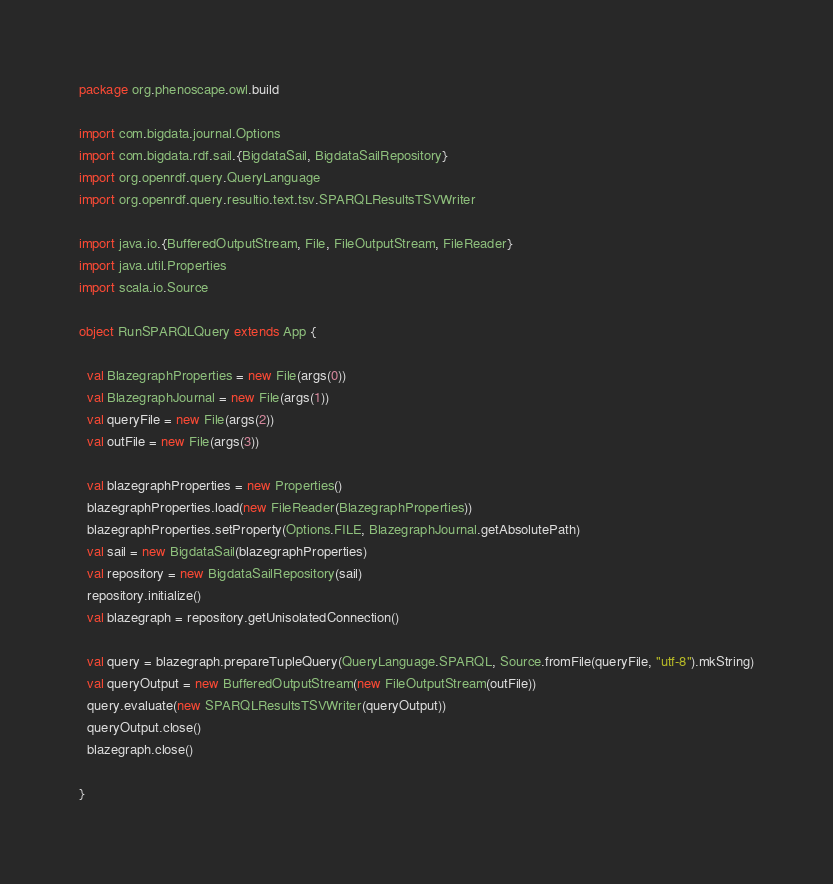Convert code to text. <code><loc_0><loc_0><loc_500><loc_500><_Scala_>package org.phenoscape.owl.build

import com.bigdata.journal.Options
import com.bigdata.rdf.sail.{BigdataSail, BigdataSailRepository}
import org.openrdf.query.QueryLanguage
import org.openrdf.query.resultio.text.tsv.SPARQLResultsTSVWriter

import java.io.{BufferedOutputStream, File, FileOutputStream, FileReader}
import java.util.Properties
import scala.io.Source

object RunSPARQLQuery extends App {

  val BlazegraphProperties = new File(args(0))
  val BlazegraphJournal = new File(args(1))
  val queryFile = new File(args(2))
  val outFile = new File(args(3))

  val blazegraphProperties = new Properties()
  blazegraphProperties.load(new FileReader(BlazegraphProperties))
  blazegraphProperties.setProperty(Options.FILE, BlazegraphJournal.getAbsolutePath)
  val sail = new BigdataSail(blazegraphProperties)
  val repository = new BigdataSailRepository(sail)
  repository.initialize()
  val blazegraph = repository.getUnisolatedConnection()

  val query = blazegraph.prepareTupleQuery(QueryLanguage.SPARQL, Source.fromFile(queryFile, "utf-8").mkString)
  val queryOutput = new BufferedOutputStream(new FileOutputStream(outFile))
  query.evaluate(new SPARQLResultsTSVWriter(queryOutput))
  queryOutput.close()
  blazegraph.close()

}
</code> 